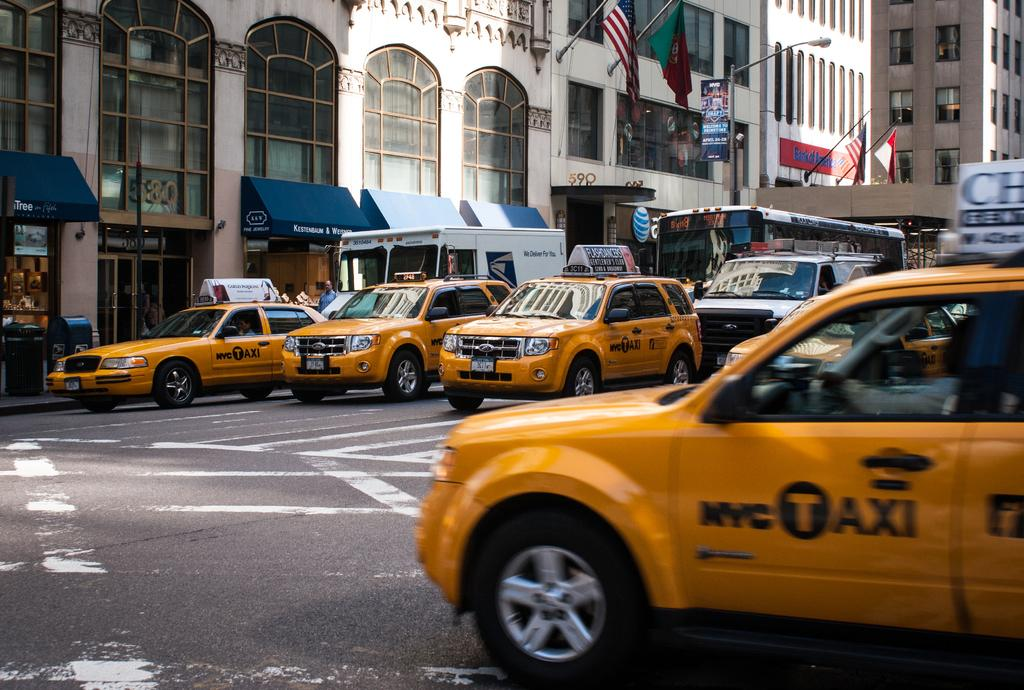What can be seen on the road in the image? There are vehicles on the road in the image. What type of structures are present in the image? There are stalls, boards, flags, and poles in the image. What can be seen in the background of the image? There are buildings in the background of the image. What type of teaching is taking place in the image? There is no teaching activity present in the image. What kind of pancake is being sold at the stalls in the image? There are no pancakes or stalls selling pancakes in the image. 